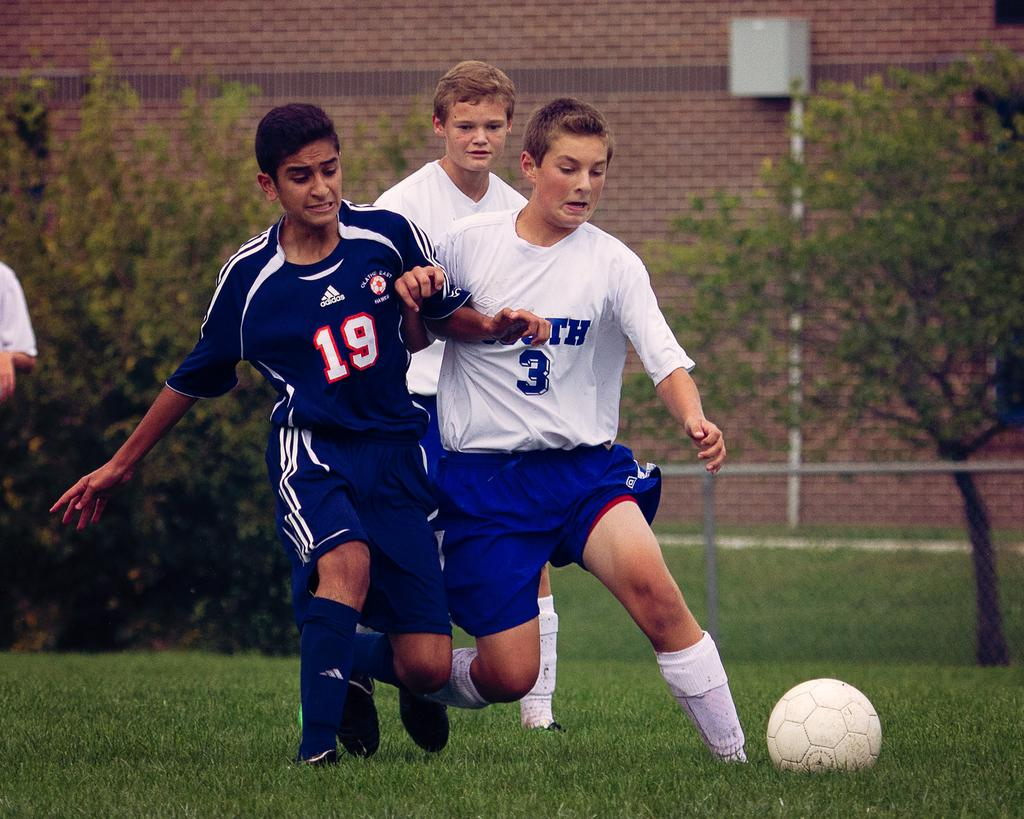<image>
Summarize the visual content of the image. A soccer player wearing number 19 is trying to steal the ball away from the player wearing number 3, of the opposite team. 